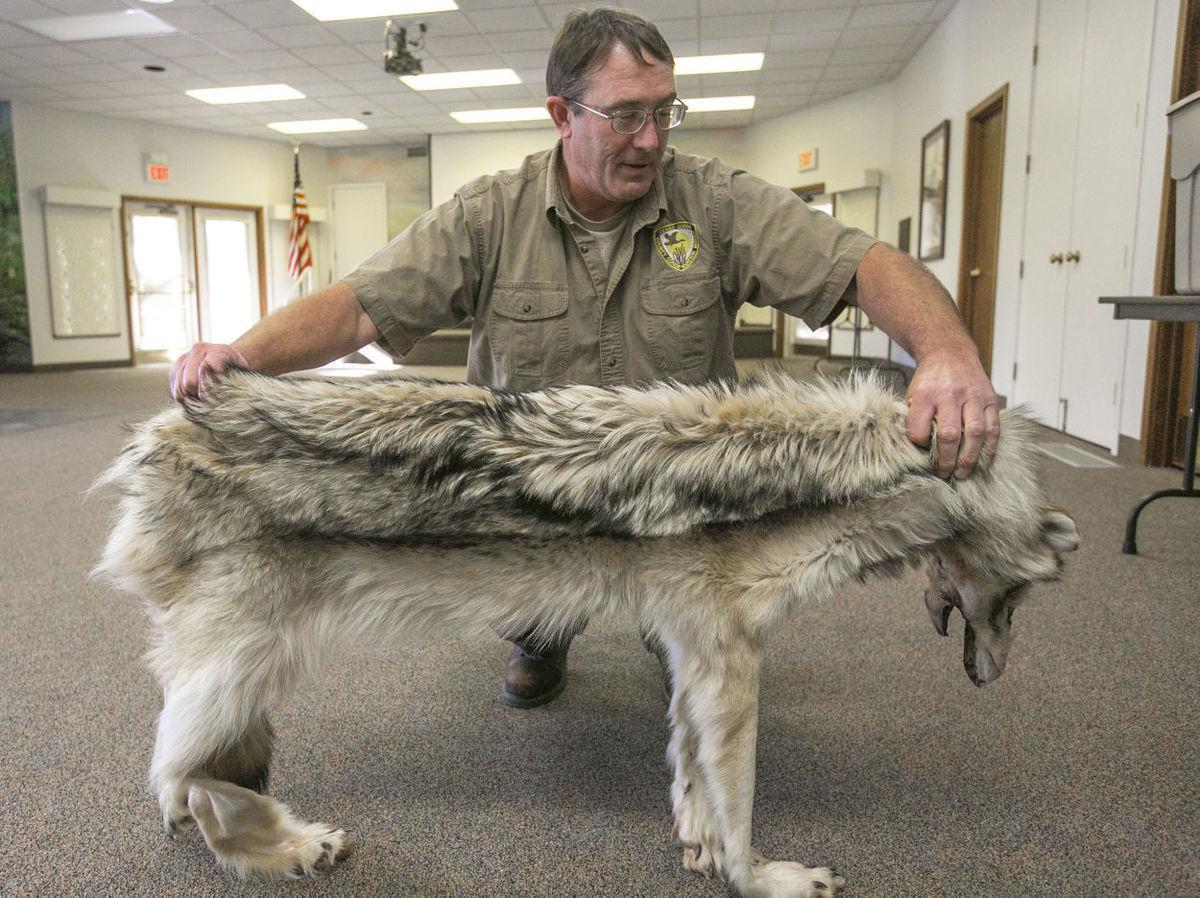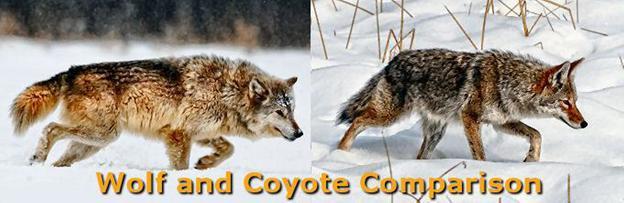The first image is the image on the left, the second image is the image on the right. Considering the images on both sides, is "The wolves are looking toward the camera." valid? Answer yes or no. No. The first image is the image on the left, the second image is the image on the right. Considering the images on both sides, is "the wolves in the image pair are looking into the camera" valid? Answer yes or no. No. 